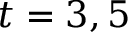<formula> <loc_0><loc_0><loc_500><loc_500>t = 3 , 5</formula> 